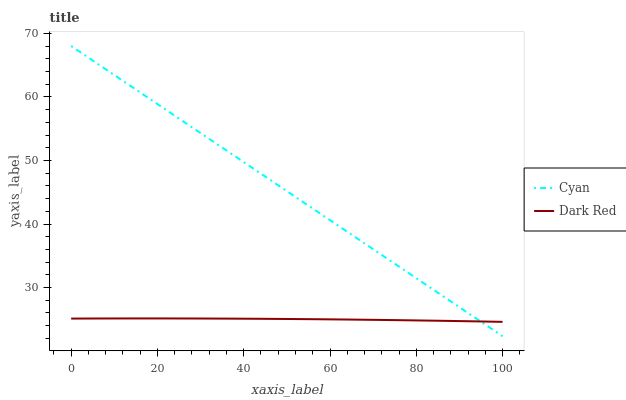Does Dark Red have the maximum area under the curve?
Answer yes or no. No. Is Dark Red the smoothest?
Answer yes or no. No. Does Dark Red have the lowest value?
Answer yes or no. No. Does Dark Red have the highest value?
Answer yes or no. No. 